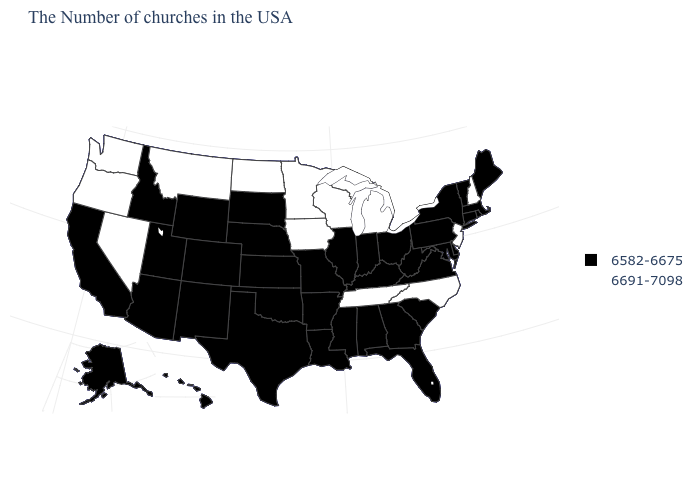What is the value of Arizona?
Be succinct. 6582-6675. What is the value of Alaska?
Keep it brief. 6582-6675. What is the value of Connecticut?
Quick response, please. 6582-6675. Name the states that have a value in the range 6691-7098?
Quick response, please. New Hampshire, New Jersey, North Carolina, Michigan, Tennessee, Wisconsin, Minnesota, Iowa, North Dakota, Montana, Nevada, Washington, Oregon. Name the states that have a value in the range 6691-7098?
Give a very brief answer. New Hampshire, New Jersey, North Carolina, Michigan, Tennessee, Wisconsin, Minnesota, Iowa, North Dakota, Montana, Nevada, Washington, Oregon. Among the states that border Utah , does Idaho have the highest value?
Quick response, please. No. How many symbols are there in the legend?
Be succinct. 2. Name the states that have a value in the range 6582-6675?
Quick response, please. Maine, Massachusetts, Rhode Island, Vermont, Connecticut, New York, Delaware, Maryland, Pennsylvania, Virginia, South Carolina, West Virginia, Ohio, Florida, Georgia, Kentucky, Indiana, Alabama, Illinois, Mississippi, Louisiana, Missouri, Arkansas, Kansas, Nebraska, Oklahoma, Texas, South Dakota, Wyoming, Colorado, New Mexico, Utah, Arizona, Idaho, California, Alaska, Hawaii. What is the lowest value in states that border Florida?
Write a very short answer. 6582-6675. Does the map have missing data?
Write a very short answer. No. Name the states that have a value in the range 6582-6675?
Keep it brief. Maine, Massachusetts, Rhode Island, Vermont, Connecticut, New York, Delaware, Maryland, Pennsylvania, Virginia, South Carolina, West Virginia, Ohio, Florida, Georgia, Kentucky, Indiana, Alabama, Illinois, Mississippi, Louisiana, Missouri, Arkansas, Kansas, Nebraska, Oklahoma, Texas, South Dakota, Wyoming, Colorado, New Mexico, Utah, Arizona, Idaho, California, Alaska, Hawaii. What is the highest value in states that border South Carolina?
Quick response, please. 6691-7098. Which states have the lowest value in the MidWest?
Write a very short answer. Ohio, Indiana, Illinois, Missouri, Kansas, Nebraska, South Dakota. What is the value of Vermont?
Answer briefly. 6582-6675. 